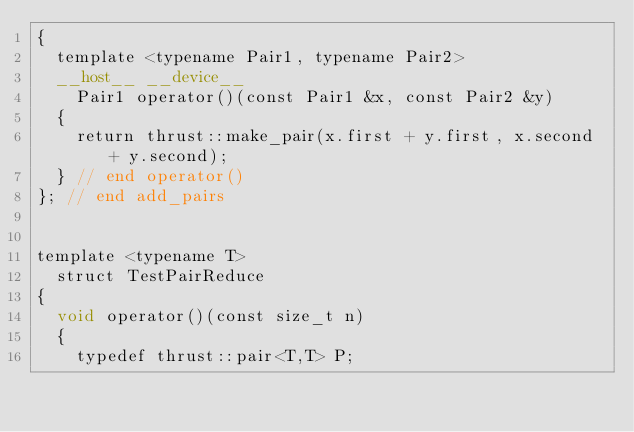<code> <loc_0><loc_0><loc_500><loc_500><_Cuda_>{
  template <typename Pair1, typename Pair2>
  __host__ __device__
    Pair1 operator()(const Pair1 &x, const Pair2 &y)
  {
    return thrust::make_pair(x.first + y.first, x.second + y.second);
  } // end operator()
}; // end add_pairs


template <typename T>
  struct TestPairReduce
{
  void operator()(const size_t n)
  {
    typedef thrust::pair<T,T> P;
</code> 